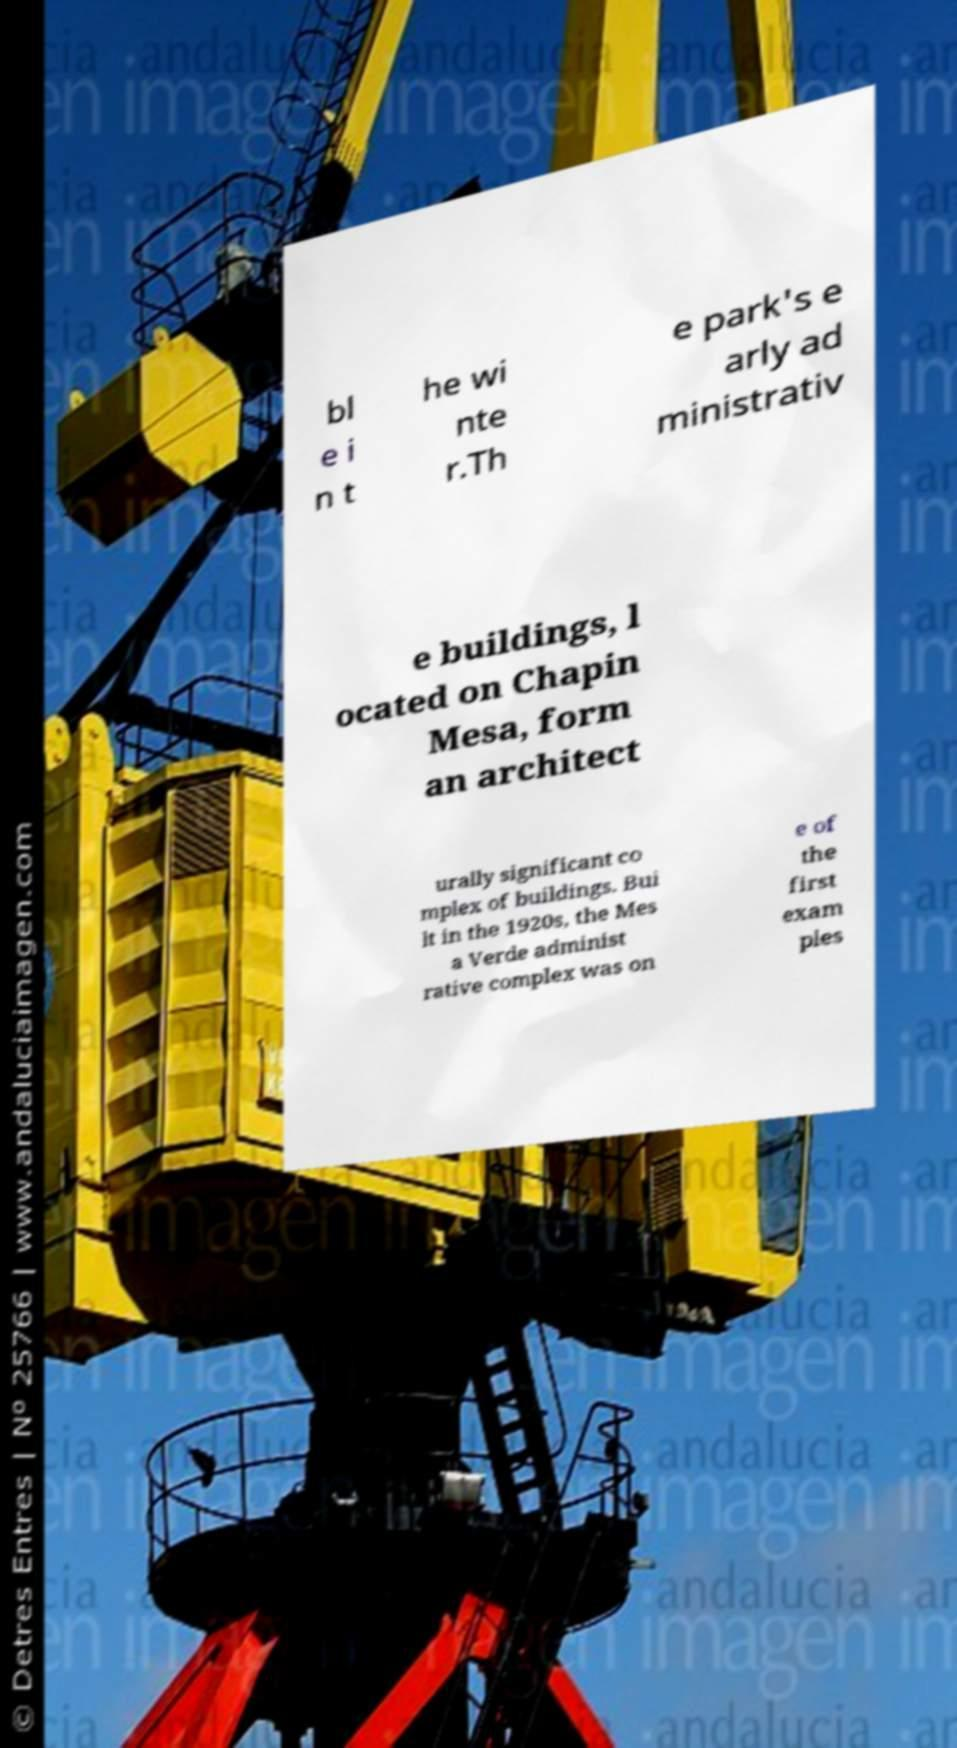There's text embedded in this image that I need extracted. Can you transcribe it verbatim? bl e i n t he wi nte r.Th e park's e arly ad ministrativ e buildings, l ocated on Chapin Mesa, form an architect urally significant co mplex of buildings. Bui lt in the 1920s, the Mes a Verde administ rative complex was on e of the first exam ples 